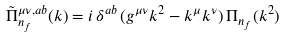<formula> <loc_0><loc_0><loc_500><loc_500>\tilde { \Pi } ^ { \mu \nu , a b } _ { n _ { f } } ( k ) = i \, \delta ^ { a b } \, ( g ^ { \mu \nu } k ^ { 2 } - k ^ { \mu } k ^ { \nu } ) \, \Pi _ { n _ { f } } ( k ^ { 2 } )</formula> 